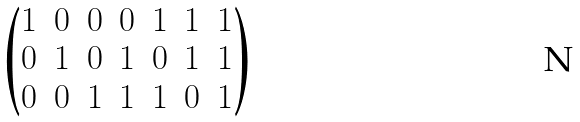<formula> <loc_0><loc_0><loc_500><loc_500>\begin{pmatrix} 1 & 0 & 0 & 0 & 1 & 1 & 1 \\ 0 & 1 & 0 & 1 & 0 & 1 & 1 \\ 0 & 0 & 1 & 1 & 1 & 0 & 1 \end{pmatrix}</formula> 